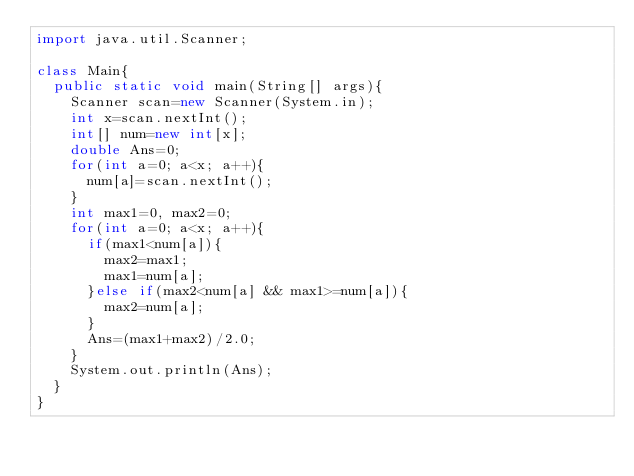Convert code to text. <code><loc_0><loc_0><loc_500><loc_500><_Java_>import java.util.Scanner;

class Main{
  public static void main(String[] args){
    Scanner scan=new Scanner(System.in);
    int x=scan.nextInt();
    int[] num=new int[x];
    double Ans=0;
    for(int a=0; a<x; a++){
      num[a]=scan.nextInt();
    }
    int max1=0, max2=0;
    for(int a=0; a<x; a++){
      if(max1<num[a]){
        max2=max1;
        max1=num[a];
      }else if(max2<num[a] && max1>=num[a]){
        max2=num[a];
      }
      Ans=(max1+max2)/2.0;
    }
    System.out.println(Ans);
  }
}</code> 